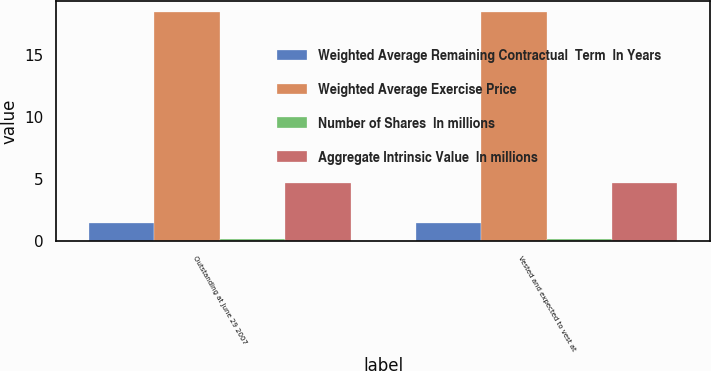Convert chart. <chart><loc_0><loc_0><loc_500><loc_500><stacked_bar_chart><ecel><fcel>Outstanding at June 29 2007<fcel>Vested and expected to vest at<nl><fcel>Weighted Average Remaining Contractual  Term  In Years<fcel>1.5<fcel>1.5<nl><fcel>Weighted Average Exercise Price<fcel>18.5<fcel>18.5<nl><fcel>Number of Shares  In millions<fcel>0.2<fcel>0.2<nl><fcel>Aggregate Intrinsic Value  In millions<fcel>4.7<fcel>4.7<nl></chart> 